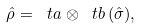Convert formula to latex. <formula><loc_0><loc_0><loc_500><loc_500>\hat { \rho } = \ t a \otimes \ t b \, ( \hat { \sigma } ) ,</formula> 